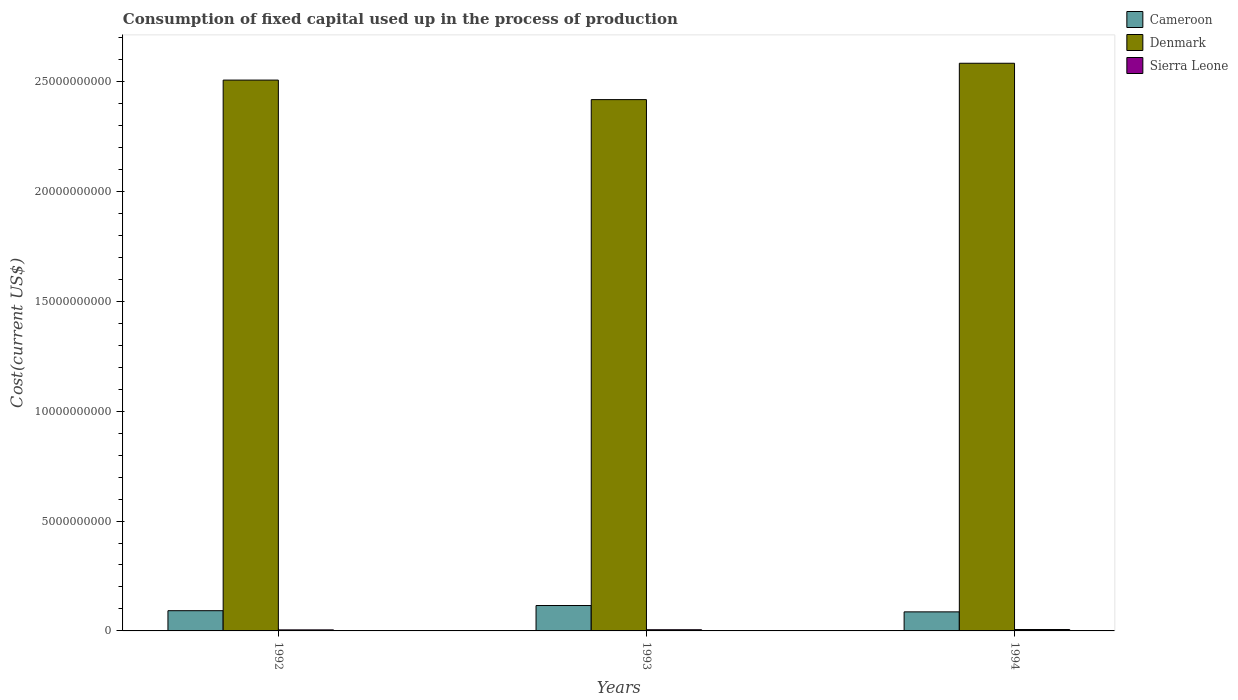How many different coloured bars are there?
Your answer should be compact. 3. How many groups of bars are there?
Your answer should be compact. 3. Are the number of bars per tick equal to the number of legend labels?
Make the answer very short. Yes. Are the number of bars on each tick of the X-axis equal?
Provide a short and direct response. Yes. How many bars are there on the 3rd tick from the right?
Your answer should be compact. 3. What is the label of the 1st group of bars from the left?
Keep it short and to the point. 1992. What is the amount consumed in the process of production in Cameroon in 1993?
Your answer should be compact. 1.16e+09. Across all years, what is the maximum amount consumed in the process of production in Denmark?
Make the answer very short. 2.58e+1. Across all years, what is the minimum amount consumed in the process of production in Cameroon?
Give a very brief answer. 8.67e+08. In which year was the amount consumed in the process of production in Denmark maximum?
Make the answer very short. 1994. What is the total amount consumed in the process of production in Cameroon in the graph?
Make the answer very short. 2.94e+09. What is the difference between the amount consumed in the process of production in Denmark in 1992 and that in 1993?
Your answer should be very brief. 8.88e+08. What is the difference between the amount consumed in the process of production in Sierra Leone in 1993 and the amount consumed in the process of production in Denmark in 1994?
Your response must be concise. -2.58e+1. What is the average amount consumed in the process of production in Sierra Leone per year?
Make the answer very short. 5.51e+07. In the year 1992, what is the difference between the amount consumed in the process of production in Denmark and amount consumed in the process of production in Sierra Leone?
Give a very brief answer. 2.50e+1. What is the ratio of the amount consumed in the process of production in Denmark in 1992 to that in 1994?
Give a very brief answer. 0.97. Is the difference between the amount consumed in the process of production in Denmark in 1992 and 1993 greater than the difference between the amount consumed in the process of production in Sierra Leone in 1992 and 1993?
Provide a short and direct response. Yes. What is the difference between the highest and the second highest amount consumed in the process of production in Sierra Leone?
Your answer should be very brief. 9.91e+06. What is the difference between the highest and the lowest amount consumed in the process of production in Denmark?
Offer a terse response. 1.65e+09. In how many years, is the amount consumed in the process of production in Cameroon greater than the average amount consumed in the process of production in Cameroon taken over all years?
Provide a succinct answer. 1. What does the 1st bar from the left in 1994 represents?
Offer a very short reply. Cameroon. What does the 2nd bar from the right in 1993 represents?
Make the answer very short. Denmark. How many bars are there?
Your answer should be compact. 9. What is the difference between two consecutive major ticks on the Y-axis?
Keep it short and to the point. 5.00e+09. Does the graph contain any zero values?
Your response must be concise. No. Does the graph contain grids?
Your response must be concise. No. Where does the legend appear in the graph?
Provide a succinct answer. Top right. How many legend labels are there?
Ensure brevity in your answer.  3. How are the legend labels stacked?
Your answer should be compact. Vertical. What is the title of the graph?
Your response must be concise. Consumption of fixed capital used up in the process of production. What is the label or title of the Y-axis?
Offer a terse response. Cost(current US$). What is the Cost(current US$) in Cameroon in 1992?
Offer a terse response. 9.21e+08. What is the Cost(current US$) of Denmark in 1992?
Give a very brief answer. 2.51e+1. What is the Cost(current US$) in Sierra Leone in 1992?
Offer a terse response. 4.75e+07. What is the Cost(current US$) of Cameroon in 1993?
Ensure brevity in your answer.  1.16e+09. What is the Cost(current US$) in Denmark in 1993?
Provide a succinct answer. 2.42e+1. What is the Cost(current US$) in Sierra Leone in 1993?
Your answer should be compact. 5.39e+07. What is the Cost(current US$) in Cameroon in 1994?
Ensure brevity in your answer.  8.67e+08. What is the Cost(current US$) of Denmark in 1994?
Your response must be concise. 2.58e+1. What is the Cost(current US$) of Sierra Leone in 1994?
Make the answer very short. 6.38e+07. Across all years, what is the maximum Cost(current US$) of Cameroon?
Keep it short and to the point. 1.16e+09. Across all years, what is the maximum Cost(current US$) in Denmark?
Give a very brief answer. 2.58e+1. Across all years, what is the maximum Cost(current US$) in Sierra Leone?
Your answer should be very brief. 6.38e+07. Across all years, what is the minimum Cost(current US$) of Cameroon?
Ensure brevity in your answer.  8.67e+08. Across all years, what is the minimum Cost(current US$) of Denmark?
Offer a terse response. 2.42e+1. Across all years, what is the minimum Cost(current US$) of Sierra Leone?
Give a very brief answer. 4.75e+07. What is the total Cost(current US$) of Cameroon in the graph?
Provide a succinct answer. 2.94e+09. What is the total Cost(current US$) of Denmark in the graph?
Your answer should be very brief. 7.51e+1. What is the total Cost(current US$) in Sierra Leone in the graph?
Offer a very short reply. 1.65e+08. What is the difference between the Cost(current US$) in Cameroon in 1992 and that in 1993?
Offer a terse response. -2.35e+08. What is the difference between the Cost(current US$) of Denmark in 1992 and that in 1993?
Provide a short and direct response. 8.88e+08. What is the difference between the Cost(current US$) in Sierra Leone in 1992 and that in 1993?
Make the answer very short. -6.40e+06. What is the difference between the Cost(current US$) in Cameroon in 1992 and that in 1994?
Your answer should be compact. 5.35e+07. What is the difference between the Cost(current US$) of Denmark in 1992 and that in 1994?
Ensure brevity in your answer.  -7.66e+08. What is the difference between the Cost(current US$) in Sierra Leone in 1992 and that in 1994?
Provide a short and direct response. -1.63e+07. What is the difference between the Cost(current US$) of Cameroon in 1993 and that in 1994?
Your answer should be compact. 2.89e+08. What is the difference between the Cost(current US$) in Denmark in 1993 and that in 1994?
Provide a short and direct response. -1.65e+09. What is the difference between the Cost(current US$) in Sierra Leone in 1993 and that in 1994?
Make the answer very short. -9.91e+06. What is the difference between the Cost(current US$) in Cameroon in 1992 and the Cost(current US$) in Denmark in 1993?
Your answer should be compact. -2.33e+1. What is the difference between the Cost(current US$) in Cameroon in 1992 and the Cost(current US$) in Sierra Leone in 1993?
Make the answer very short. 8.67e+08. What is the difference between the Cost(current US$) of Denmark in 1992 and the Cost(current US$) of Sierra Leone in 1993?
Your answer should be compact. 2.50e+1. What is the difference between the Cost(current US$) of Cameroon in 1992 and the Cost(current US$) of Denmark in 1994?
Give a very brief answer. -2.49e+1. What is the difference between the Cost(current US$) in Cameroon in 1992 and the Cost(current US$) in Sierra Leone in 1994?
Keep it short and to the point. 8.57e+08. What is the difference between the Cost(current US$) in Denmark in 1992 and the Cost(current US$) in Sierra Leone in 1994?
Give a very brief answer. 2.50e+1. What is the difference between the Cost(current US$) of Cameroon in 1993 and the Cost(current US$) of Denmark in 1994?
Provide a succinct answer. -2.47e+1. What is the difference between the Cost(current US$) of Cameroon in 1993 and the Cost(current US$) of Sierra Leone in 1994?
Provide a short and direct response. 1.09e+09. What is the difference between the Cost(current US$) of Denmark in 1993 and the Cost(current US$) of Sierra Leone in 1994?
Provide a short and direct response. 2.41e+1. What is the average Cost(current US$) in Cameroon per year?
Keep it short and to the point. 9.81e+08. What is the average Cost(current US$) of Denmark per year?
Ensure brevity in your answer.  2.50e+1. What is the average Cost(current US$) of Sierra Leone per year?
Offer a very short reply. 5.51e+07. In the year 1992, what is the difference between the Cost(current US$) of Cameroon and Cost(current US$) of Denmark?
Your answer should be compact. -2.41e+1. In the year 1992, what is the difference between the Cost(current US$) of Cameroon and Cost(current US$) of Sierra Leone?
Provide a short and direct response. 8.73e+08. In the year 1992, what is the difference between the Cost(current US$) in Denmark and Cost(current US$) in Sierra Leone?
Provide a short and direct response. 2.50e+1. In the year 1993, what is the difference between the Cost(current US$) of Cameroon and Cost(current US$) of Denmark?
Offer a very short reply. -2.30e+1. In the year 1993, what is the difference between the Cost(current US$) of Cameroon and Cost(current US$) of Sierra Leone?
Your answer should be compact. 1.10e+09. In the year 1993, what is the difference between the Cost(current US$) in Denmark and Cost(current US$) in Sierra Leone?
Provide a succinct answer. 2.41e+1. In the year 1994, what is the difference between the Cost(current US$) of Cameroon and Cost(current US$) of Denmark?
Your response must be concise. -2.50e+1. In the year 1994, what is the difference between the Cost(current US$) in Cameroon and Cost(current US$) in Sierra Leone?
Make the answer very short. 8.03e+08. In the year 1994, what is the difference between the Cost(current US$) of Denmark and Cost(current US$) of Sierra Leone?
Offer a very short reply. 2.58e+1. What is the ratio of the Cost(current US$) of Cameroon in 1992 to that in 1993?
Make the answer very short. 0.8. What is the ratio of the Cost(current US$) in Denmark in 1992 to that in 1993?
Your response must be concise. 1.04. What is the ratio of the Cost(current US$) of Sierra Leone in 1992 to that in 1993?
Provide a succinct answer. 0.88. What is the ratio of the Cost(current US$) in Cameroon in 1992 to that in 1994?
Offer a terse response. 1.06. What is the ratio of the Cost(current US$) in Denmark in 1992 to that in 1994?
Offer a terse response. 0.97. What is the ratio of the Cost(current US$) in Sierra Leone in 1992 to that in 1994?
Your response must be concise. 0.74. What is the ratio of the Cost(current US$) in Cameroon in 1993 to that in 1994?
Make the answer very short. 1.33. What is the ratio of the Cost(current US$) in Denmark in 1993 to that in 1994?
Make the answer very short. 0.94. What is the ratio of the Cost(current US$) of Sierra Leone in 1993 to that in 1994?
Make the answer very short. 0.84. What is the difference between the highest and the second highest Cost(current US$) in Cameroon?
Offer a very short reply. 2.35e+08. What is the difference between the highest and the second highest Cost(current US$) of Denmark?
Make the answer very short. 7.66e+08. What is the difference between the highest and the second highest Cost(current US$) of Sierra Leone?
Give a very brief answer. 9.91e+06. What is the difference between the highest and the lowest Cost(current US$) of Cameroon?
Offer a terse response. 2.89e+08. What is the difference between the highest and the lowest Cost(current US$) in Denmark?
Keep it short and to the point. 1.65e+09. What is the difference between the highest and the lowest Cost(current US$) in Sierra Leone?
Offer a terse response. 1.63e+07. 